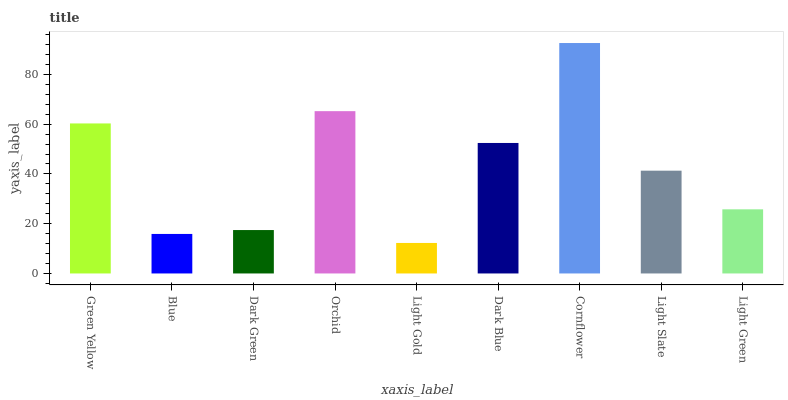Is Light Gold the minimum?
Answer yes or no. Yes. Is Cornflower the maximum?
Answer yes or no. Yes. Is Blue the minimum?
Answer yes or no. No. Is Blue the maximum?
Answer yes or no. No. Is Green Yellow greater than Blue?
Answer yes or no. Yes. Is Blue less than Green Yellow?
Answer yes or no. Yes. Is Blue greater than Green Yellow?
Answer yes or no. No. Is Green Yellow less than Blue?
Answer yes or no. No. Is Light Slate the high median?
Answer yes or no. Yes. Is Light Slate the low median?
Answer yes or no. Yes. Is Green Yellow the high median?
Answer yes or no. No. Is Dark Blue the low median?
Answer yes or no. No. 